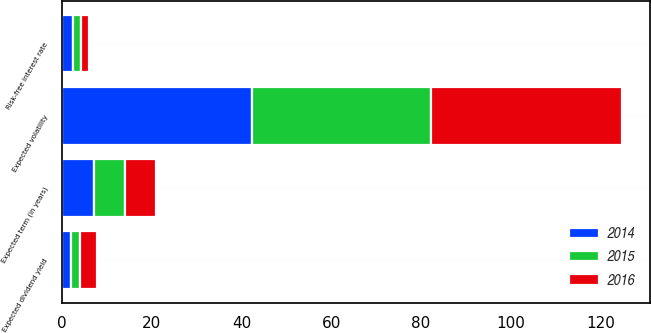Convert chart. <chart><loc_0><loc_0><loc_500><loc_500><stacked_bar_chart><ecel><fcel>Expected volatility<fcel>Expected dividend yield<fcel>Expected term (in years)<fcel>Risk-free interest rate<nl><fcel>2016<fcel>42.54<fcel>3.86<fcel>7<fcel>1.65<nl><fcel>2015<fcel>39.9<fcel>1.98<fcel>7<fcel>1.92<nl><fcel>2014<fcel>42.4<fcel>2.01<fcel>7<fcel>2.31<nl></chart> 